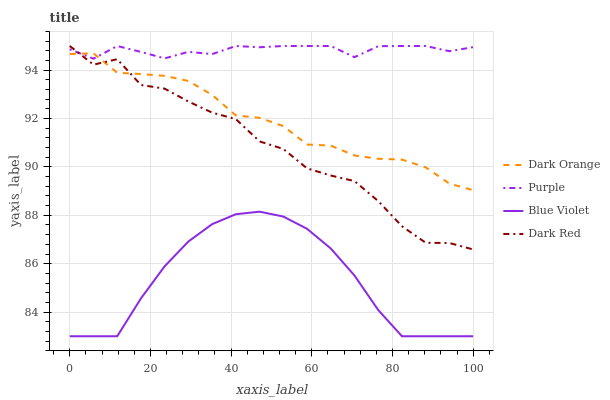Does Blue Violet have the minimum area under the curve?
Answer yes or no. Yes. Does Purple have the maximum area under the curve?
Answer yes or no. Yes. Does Dark Orange have the minimum area under the curve?
Answer yes or no. No. Does Dark Orange have the maximum area under the curve?
Answer yes or no. No. Is Blue Violet the smoothest?
Answer yes or no. Yes. Is Dark Red the roughest?
Answer yes or no. Yes. Is Dark Orange the smoothest?
Answer yes or no. No. Is Dark Orange the roughest?
Answer yes or no. No. Does Dark Orange have the lowest value?
Answer yes or no. No. Does Dark Red have the highest value?
Answer yes or no. Yes. Does Dark Orange have the highest value?
Answer yes or no. No. Is Blue Violet less than Dark Red?
Answer yes or no. Yes. Is Dark Orange greater than Blue Violet?
Answer yes or no. Yes. Does Purple intersect Dark Orange?
Answer yes or no. Yes. Is Purple less than Dark Orange?
Answer yes or no. No. Is Purple greater than Dark Orange?
Answer yes or no. No. Does Blue Violet intersect Dark Red?
Answer yes or no. No. 